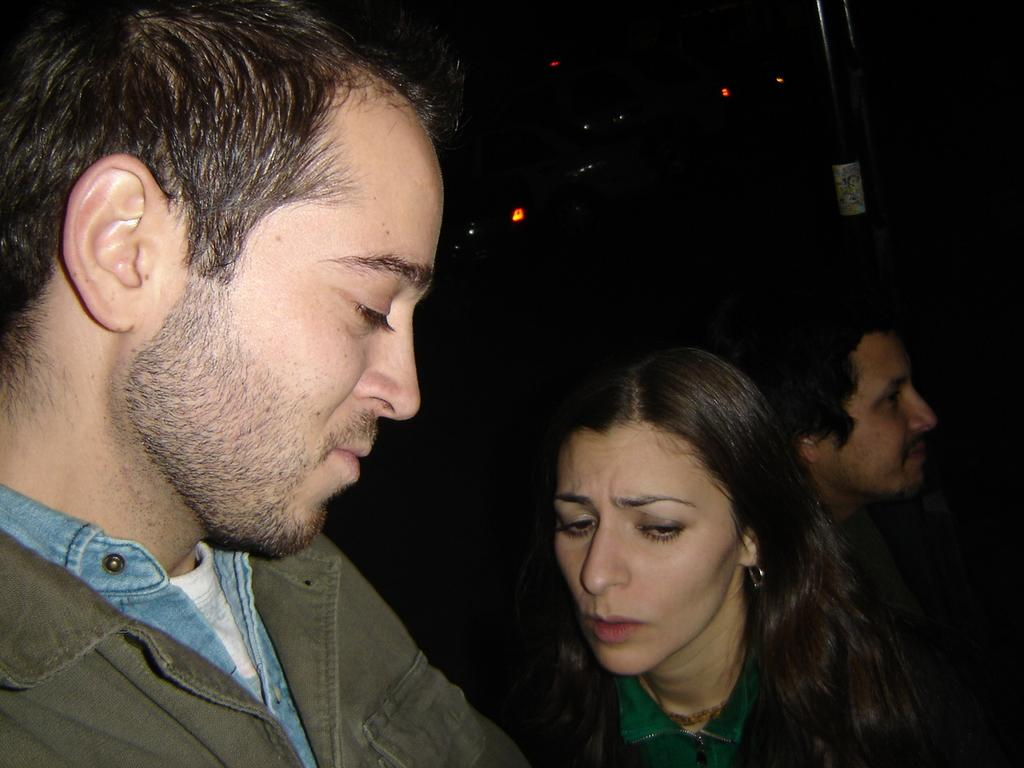How many people are in the foreground of the image? There are two men and a woman in the foreground of the image. What is the lighting condition in the image? The scene appears to be dark. What can be seen on the right side of the image? There is a pole on the right side of the image. How many sheep are visible in the image? There are no sheep present in the image. What is being smashed in the image? There is no smashing activity depicted in the image. 